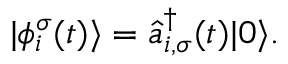<formula> <loc_0><loc_0><loc_500><loc_500>| \phi _ { i } ^ { \sigma } ( t ) \rangle = \hat { a } _ { i , \sigma } ^ { \dagger } ( t ) | 0 \rangle .</formula> 